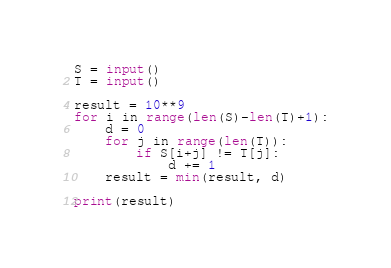Convert code to text. <code><loc_0><loc_0><loc_500><loc_500><_Python_>S = input()
T = input()

result = 10**9
for i in range(len(S)-len(T)+1):
    d = 0
    for j in range(len(T)):
        if S[i+j] != T[j]:
            d += 1
    result = min(result, d)

print(result)
</code> 